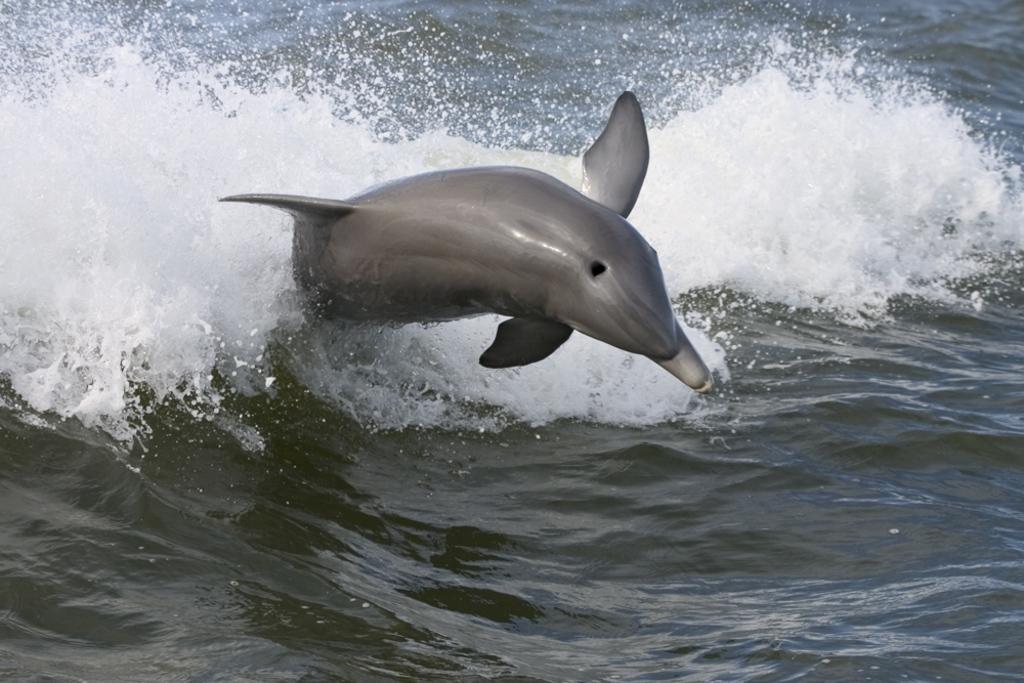Please provide a concise description of this image. There is a dolphin jumping in water. 